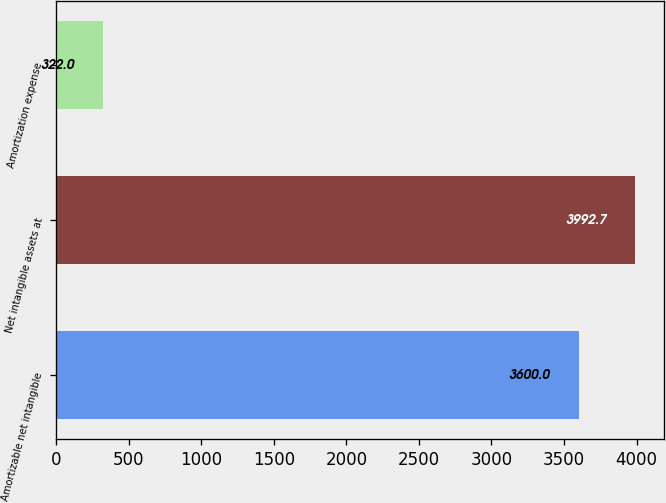<chart> <loc_0><loc_0><loc_500><loc_500><bar_chart><fcel>Amortizable net intangible<fcel>Net intangible assets at<fcel>Amortization expense<nl><fcel>3600<fcel>3992.7<fcel>322<nl></chart> 